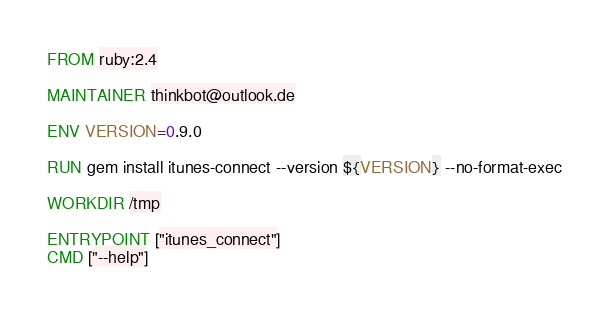Convert code to text. <code><loc_0><loc_0><loc_500><loc_500><_Dockerfile_>FROM ruby:2.4

MAINTAINER thinkbot@outlook.de

ENV VERSION=0.9.0

RUN gem install itunes-connect --version ${VERSION} --no-format-exec

WORKDIR /tmp

ENTRYPOINT ["itunes_connect"]
CMD ["--help"]
</code> 